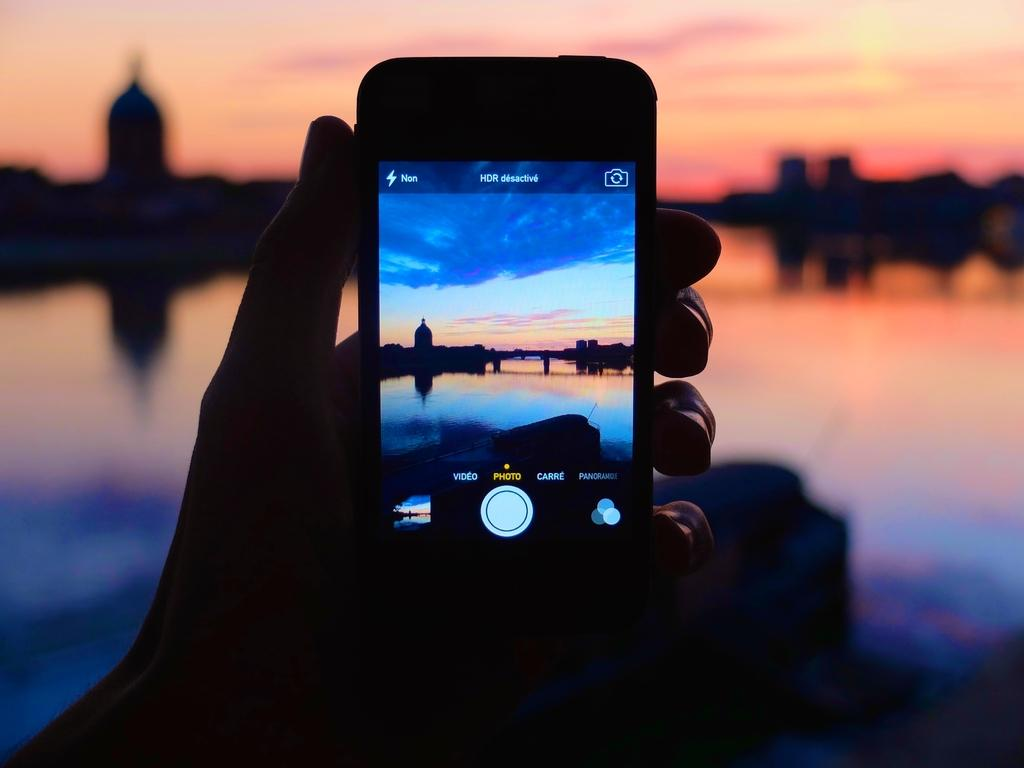<image>
Create a compact narrative representing the image presented. A person is holding up a cell phone that is in photo mode. 